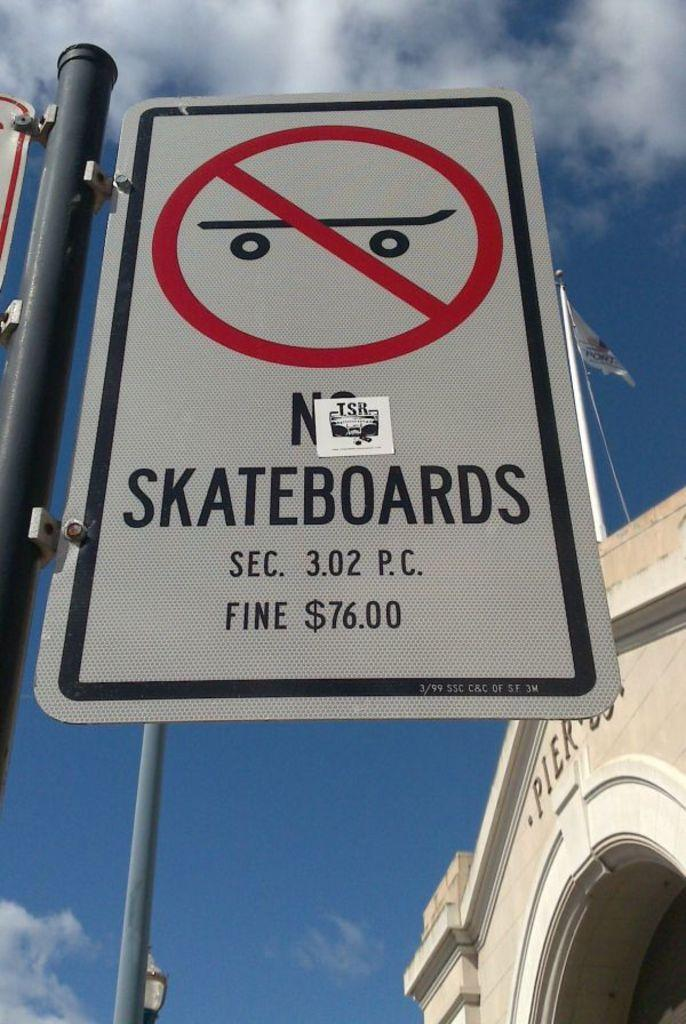<image>
Summarize the visual content of the image. A city street sign that says no skateboards. 